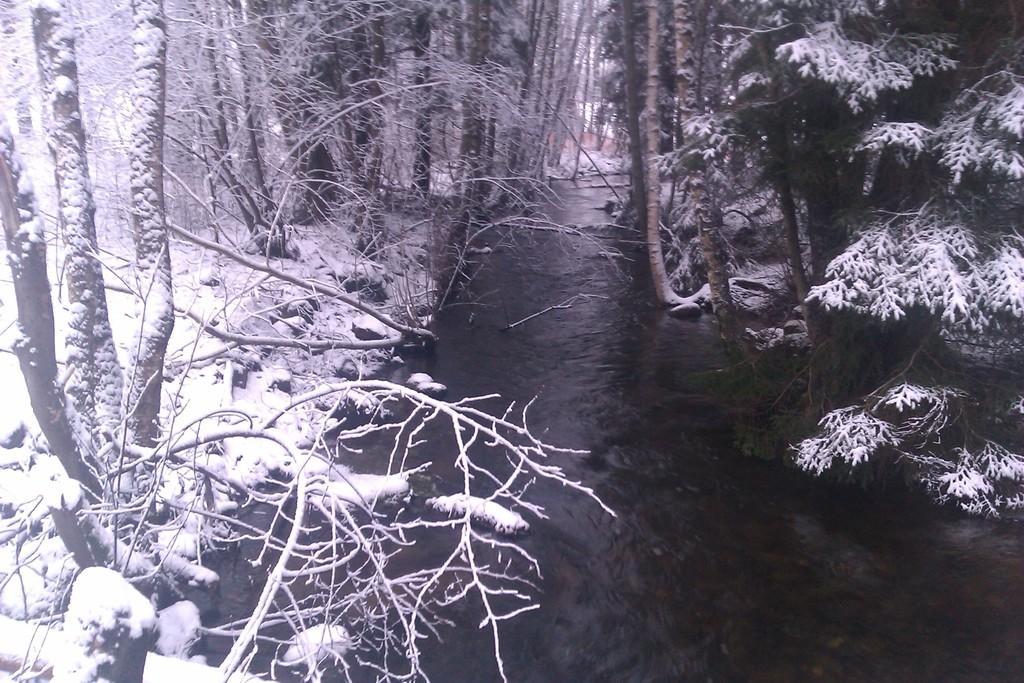Describe this image in one or two sentences. In this image there is a river in the middle of this image ,and there are some trees in the background. 